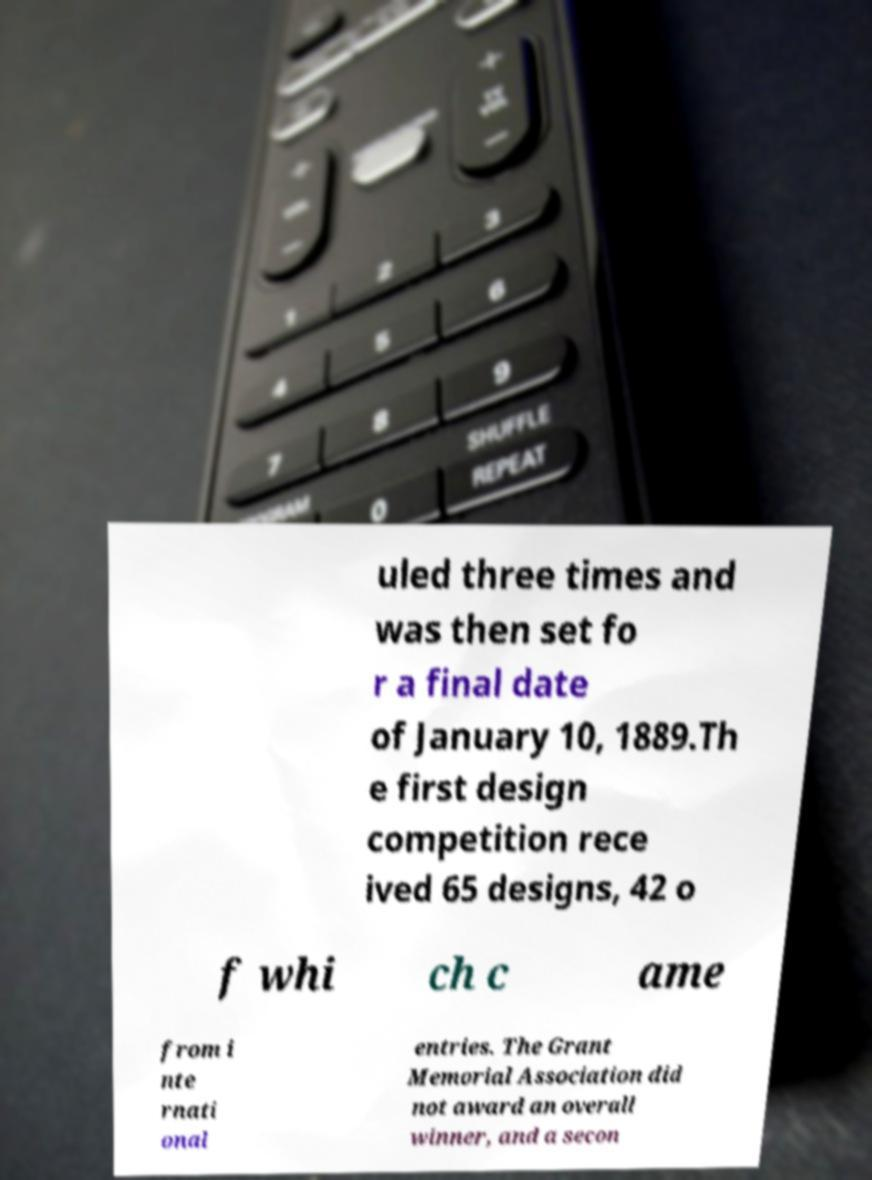Can you read and provide the text displayed in the image?This photo seems to have some interesting text. Can you extract and type it out for me? uled three times and was then set fo r a final date of January 10, 1889.Th e first design competition rece ived 65 designs, 42 o f whi ch c ame from i nte rnati onal entries. The Grant Memorial Association did not award an overall winner, and a secon 